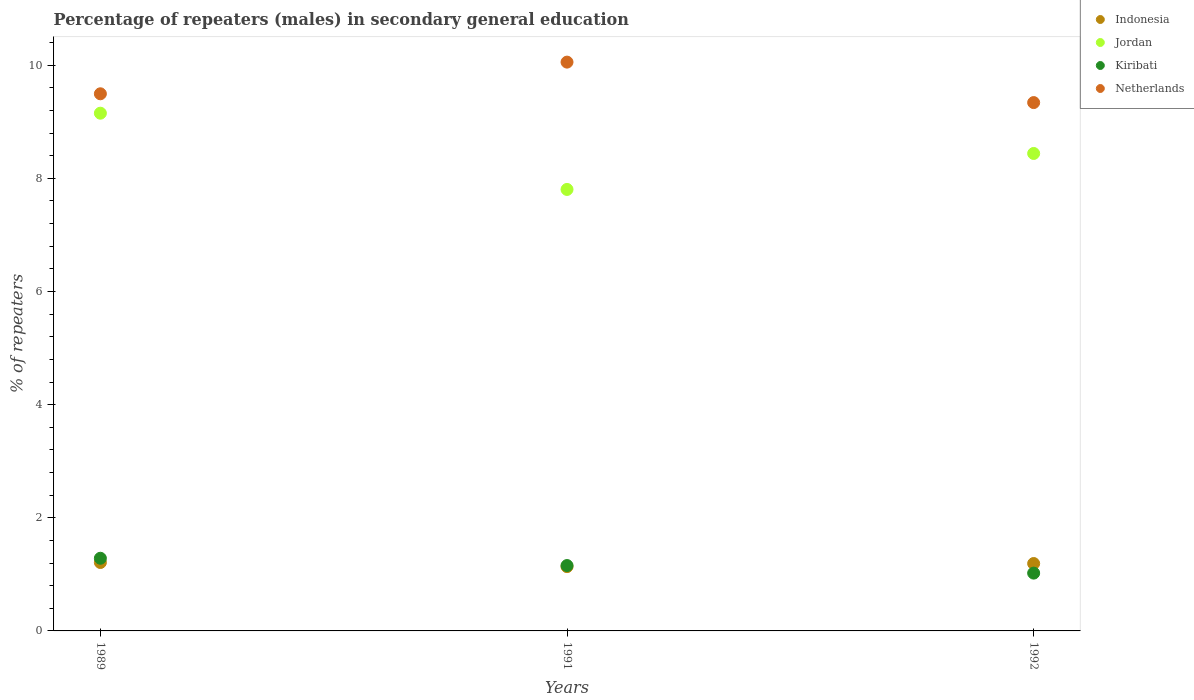How many different coloured dotlines are there?
Provide a short and direct response. 4. What is the percentage of male repeaters in Jordan in 1992?
Provide a short and direct response. 8.44. Across all years, what is the maximum percentage of male repeaters in Netherlands?
Keep it short and to the point. 10.05. Across all years, what is the minimum percentage of male repeaters in Kiribati?
Your answer should be very brief. 1.02. In which year was the percentage of male repeaters in Jordan maximum?
Give a very brief answer. 1989. What is the total percentage of male repeaters in Jordan in the graph?
Offer a terse response. 25.4. What is the difference between the percentage of male repeaters in Kiribati in 1991 and that in 1992?
Offer a very short reply. 0.13. What is the difference between the percentage of male repeaters in Indonesia in 1992 and the percentage of male repeaters in Jordan in 1989?
Ensure brevity in your answer.  -7.96. What is the average percentage of male repeaters in Indonesia per year?
Make the answer very short. 1.18. In the year 1991, what is the difference between the percentage of male repeaters in Netherlands and percentage of male repeaters in Indonesia?
Your answer should be very brief. 8.92. In how many years, is the percentage of male repeaters in Indonesia greater than 8.4 %?
Offer a terse response. 0. What is the ratio of the percentage of male repeaters in Indonesia in 1991 to that in 1992?
Provide a short and direct response. 0.95. Is the percentage of male repeaters in Kiribati in 1989 less than that in 1991?
Provide a succinct answer. No. Is the difference between the percentage of male repeaters in Netherlands in 1989 and 1991 greater than the difference between the percentage of male repeaters in Indonesia in 1989 and 1991?
Offer a very short reply. No. What is the difference between the highest and the second highest percentage of male repeaters in Kiribati?
Keep it short and to the point. 0.13. What is the difference between the highest and the lowest percentage of male repeaters in Indonesia?
Offer a very short reply. 0.07. Is it the case that in every year, the sum of the percentage of male repeaters in Kiribati and percentage of male repeaters in Indonesia  is greater than the sum of percentage of male repeaters in Jordan and percentage of male repeaters in Netherlands?
Give a very brief answer. No. Is it the case that in every year, the sum of the percentage of male repeaters in Netherlands and percentage of male repeaters in Jordan  is greater than the percentage of male repeaters in Kiribati?
Provide a succinct answer. Yes. Does the percentage of male repeaters in Jordan monotonically increase over the years?
Make the answer very short. No. Is the percentage of male repeaters in Indonesia strictly greater than the percentage of male repeaters in Jordan over the years?
Your answer should be very brief. No. How many years are there in the graph?
Offer a terse response. 3. What is the difference between two consecutive major ticks on the Y-axis?
Your answer should be very brief. 2. Does the graph contain any zero values?
Your response must be concise. No. Does the graph contain grids?
Keep it short and to the point. No. What is the title of the graph?
Offer a very short reply. Percentage of repeaters (males) in secondary general education. What is the label or title of the X-axis?
Make the answer very short. Years. What is the label or title of the Y-axis?
Provide a succinct answer. % of repeaters. What is the % of repeaters of Indonesia in 1989?
Ensure brevity in your answer.  1.21. What is the % of repeaters in Jordan in 1989?
Ensure brevity in your answer.  9.15. What is the % of repeaters in Kiribati in 1989?
Offer a terse response. 1.28. What is the % of repeaters in Netherlands in 1989?
Offer a terse response. 9.49. What is the % of repeaters in Indonesia in 1991?
Your answer should be compact. 1.14. What is the % of repeaters of Jordan in 1991?
Give a very brief answer. 7.8. What is the % of repeaters of Kiribati in 1991?
Provide a succinct answer. 1.16. What is the % of repeaters in Netherlands in 1991?
Make the answer very short. 10.05. What is the % of repeaters of Indonesia in 1992?
Offer a very short reply. 1.19. What is the % of repeaters of Jordan in 1992?
Give a very brief answer. 8.44. What is the % of repeaters of Kiribati in 1992?
Offer a terse response. 1.02. What is the % of repeaters of Netherlands in 1992?
Your answer should be very brief. 9.34. Across all years, what is the maximum % of repeaters of Indonesia?
Keep it short and to the point. 1.21. Across all years, what is the maximum % of repeaters of Jordan?
Your answer should be very brief. 9.15. Across all years, what is the maximum % of repeaters in Kiribati?
Your answer should be compact. 1.28. Across all years, what is the maximum % of repeaters in Netherlands?
Offer a very short reply. 10.05. Across all years, what is the minimum % of repeaters of Indonesia?
Make the answer very short. 1.14. Across all years, what is the minimum % of repeaters in Jordan?
Offer a terse response. 7.8. Across all years, what is the minimum % of repeaters in Kiribati?
Offer a very short reply. 1.02. Across all years, what is the minimum % of repeaters in Netherlands?
Offer a terse response. 9.34. What is the total % of repeaters of Indonesia in the graph?
Keep it short and to the point. 3.54. What is the total % of repeaters of Jordan in the graph?
Provide a succinct answer. 25.4. What is the total % of repeaters of Kiribati in the graph?
Give a very brief answer. 3.46. What is the total % of repeaters in Netherlands in the graph?
Give a very brief answer. 28.89. What is the difference between the % of repeaters of Indonesia in 1989 and that in 1991?
Your answer should be compact. 0.07. What is the difference between the % of repeaters of Jordan in 1989 and that in 1991?
Make the answer very short. 1.35. What is the difference between the % of repeaters in Kiribati in 1989 and that in 1991?
Offer a terse response. 0.13. What is the difference between the % of repeaters in Netherlands in 1989 and that in 1991?
Offer a terse response. -0.56. What is the difference between the % of repeaters in Indonesia in 1989 and that in 1992?
Your answer should be very brief. 0.02. What is the difference between the % of repeaters of Jordan in 1989 and that in 1992?
Make the answer very short. 0.71. What is the difference between the % of repeaters in Kiribati in 1989 and that in 1992?
Provide a short and direct response. 0.26. What is the difference between the % of repeaters in Netherlands in 1989 and that in 1992?
Your answer should be very brief. 0.16. What is the difference between the % of repeaters of Indonesia in 1991 and that in 1992?
Keep it short and to the point. -0.06. What is the difference between the % of repeaters in Jordan in 1991 and that in 1992?
Offer a very short reply. -0.64. What is the difference between the % of repeaters in Kiribati in 1991 and that in 1992?
Offer a very short reply. 0.13. What is the difference between the % of repeaters in Netherlands in 1991 and that in 1992?
Give a very brief answer. 0.72. What is the difference between the % of repeaters in Indonesia in 1989 and the % of repeaters in Jordan in 1991?
Ensure brevity in your answer.  -6.59. What is the difference between the % of repeaters in Indonesia in 1989 and the % of repeaters in Kiribati in 1991?
Keep it short and to the point. 0.05. What is the difference between the % of repeaters in Indonesia in 1989 and the % of repeaters in Netherlands in 1991?
Keep it short and to the point. -8.85. What is the difference between the % of repeaters in Jordan in 1989 and the % of repeaters in Kiribati in 1991?
Provide a succinct answer. 8. What is the difference between the % of repeaters of Jordan in 1989 and the % of repeaters of Netherlands in 1991?
Ensure brevity in your answer.  -0.9. What is the difference between the % of repeaters in Kiribati in 1989 and the % of repeaters in Netherlands in 1991?
Your answer should be compact. -8.77. What is the difference between the % of repeaters in Indonesia in 1989 and the % of repeaters in Jordan in 1992?
Offer a terse response. -7.23. What is the difference between the % of repeaters in Indonesia in 1989 and the % of repeaters in Kiribati in 1992?
Offer a very short reply. 0.19. What is the difference between the % of repeaters of Indonesia in 1989 and the % of repeaters of Netherlands in 1992?
Offer a terse response. -8.13. What is the difference between the % of repeaters of Jordan in 1989 and the % of repeaters of Kiribati in 1992?
Offer a terse response. 8.13. What is the difference between the % of repeaters of Jordan in 1989 and the % of repeaters of Netherlands in 1992?
Provide a succinct answer. -0.19. What is the difference between the % of repeaters of Kiribati in 1989 and the % of repeaters of Netherlands in 1992?
Give a very brief answer. -8.05. What is the difference between the % of repeaters of Indonesia in 1991 and the % of repeaters of Jordan in 1992?
Your answer should be very brief. -7.3. What is the difference between the % of repeaters of Indonesia in 1991 and the % of repeaters of Kiribati in 1992?
Your response must be concise. 0.11. What is the difference between the % of repeaters of Indonesia in 1991 and the % of repeaters of Netherlands in 1992?
Your response must be concise. -8.2. What is the difference between the % of repeaters in Jordan in 1991 and the % of repeaters in Kiribati in 1992?
Provide a short and direct response. 6.78. What is the difference between the % of repeaters in Jordan in 1991 and the % of repeaters in Netherlands in 1992?
Provide a short and direct response. -1.54. What is the difference between the % of repeaters of Kiribati in 1991 and the % of repeaters of Netherlands in 1992?
Make the answer very short. -8.18. What is the average % of repeaters in Indonesia per year?
Provide a succinct answer. 1.18. What is the average % of repeaters of Jordan per year?
Provide a succinct answer. 8.47. What is the average % of repeaters in Kiribati per year?
Offer a terse response. 1.15. What is the average % of repeaters in Netherlands per year?
Provide a succinct answer. 9.63. In the year 1989, what is the difference between the % of repeaters in Indonesia and % of repeaters in Jordan?
Give a very brief answer. -7.94. In the year 1989, what is the difference between the % of repeaters of Indonesia and % of repeaters of Kiribati?
Your response must be concise. -0.07. In the year 1989, what is the difference between the % of repeaters of Indonesia and % of repeaters of Netherlands?
Give a very brief answer. -8.29. In the year 1989, what is the difference between the % of repeaters of Jordan and % of repeaters of Kiribati?
Make the answer very short. 7.87. In the year 1989, what is the difference between the % of repeaters of Jordan and % of repeaters of Netherlands?
Your response must be concise. -0.34. In the year 1989, what is the difference between the % of repeaters in Kiribati and % of repeaters in Netherlands?
Your answer should be compact. -8.21. In the year 1991, what is the difference between the % of repeaters of Indonesia and % of repeaters of Jordan?
Keep it short and to the point. -6.67. In the year 1991, what is the difference between the % of repeaters of Indonesia and % of repeaters of Kiribati?
Your answer should be compact. -0.02. In the year 1991, what is the difference between the % of repeaters in Indonesia and % of repeaters in Netherlands?
Your answer should be very brief. -8.92. In the year 1991, what is the difference between the % of repeaters in Jordan and % of repeaters in Kiribati?
Provide a short and direct response. 6.65. In the year 1991, what is the difference between the % of repeaters of Jordan and % of repeaters of Netherlands?
Your answer should be very brief. -2.25. In the year 1991, what is the difference between the % of repeaters in Kiribati and % of repeaters in Netherlands?
Your response must be concise. -8.9. In the year 1992, what is the difference between the % of repeaters of Indonesia and % of repeaters of Jordan?
Your response must be concise. -7.25. In the year 1992, what is the difference between the % of repeaters in Indonesia and % of repeaters in Kiribati?
Offer a very short reply. 0.17. In the year 1992, what is the difference between the % of repeaters in Indonesia and % of repeaters in Netherlands?
Your response must be concise. -8.15. In the year 1992, what is the difference between the % of repeaters of Jordan and % of repeaters of Kiribati?
Your answer should be very brief. 7.42. In the year 1992, what is the difference between the % of repeaters of Jordan and % of repeaters of Netherlands?
Make the answer very short. -0.9. In the year 1992, what is the difference between the % of repeaters in Kiribati and % of repeaters in Netherlands?
Offer a very short reply. -8.32. What is the ratio of the % of repeaters of Indonesia in 1989 to that in 1991?
Ensure brevity in your answer.  1.06. What is the ratio of the % of repeaters in Jordan in 1989 to that in 1991?
Keep it short and to the point. 1.17. What is the ratio of the % of repeaters in Kiribati in 1989 to that in 1991?
Give a very brief answer. 1.11. What is the ratio of the % of repeaters in Netherlands in 1989 to that in 1991?
Your response must be concise. 0.94. What is the ratio of the % of repeaters in Indonesia in 1989 to that in 1992?
Make the answer very short. 1.02. What is the ratio of the % of repeaters in Jordan in 1989 to that in 1992?
Your response must be concise. 1.08. What is the ratio of the % of repeaters in Kiribati in 1989 to that in 1992?
Your response must be concise. 1.26. What is the ratio of the % of repeaters in Netherlands in 1989 to that in 1992?
Offer a terse response. 1.02. What is the ratio of the % of repeaters in Indonesia in 1991 to that in 1992?
Offer a terse response. 0.95. What is the ratio of the % of repeaters of Jordan in 1991 to that in 1992?
Your answer should be very brief. 0.92. What is the ratio of the % of repeaters in Kiribati in 1991 to that in 1992?
Give a very brief answer. 1.13. What is the ratio of the % of repeaters in Netherlands in 1991 to that in 1992?
Give a very brief answer. 1.08. What is the difference between the highest and the second highest % of repeaters in Indonesia?
Provide a succinct answer. 0.02. What is the difference between the highest and the second highest % of repeaters of Jordan?
Your answer should be compact. 0.71. What is the difference between the highest and the second highest % of repeaters of Kiribati?
Give a very brief answer. 0.13. What is the difference between the highest and the second highest % of repeaters in Netherlands?
Keep it short and to the point. 0.56. What is the difference between the highest and the lowest % of repeaters of Indonesia?
Give a very brief answer. 0.07. What is the difference between the highest and the lowest % of repeaters of Jordan?
Offer a very short reply. 1.35. What is the difference between the highest and the lowest % of repeaters of Kiribati?
Offer a very short reply. 0.26. What is the difference between the highest and the lowest % of repeaters in Netherlands?
Make the answer very short. 0.72. 